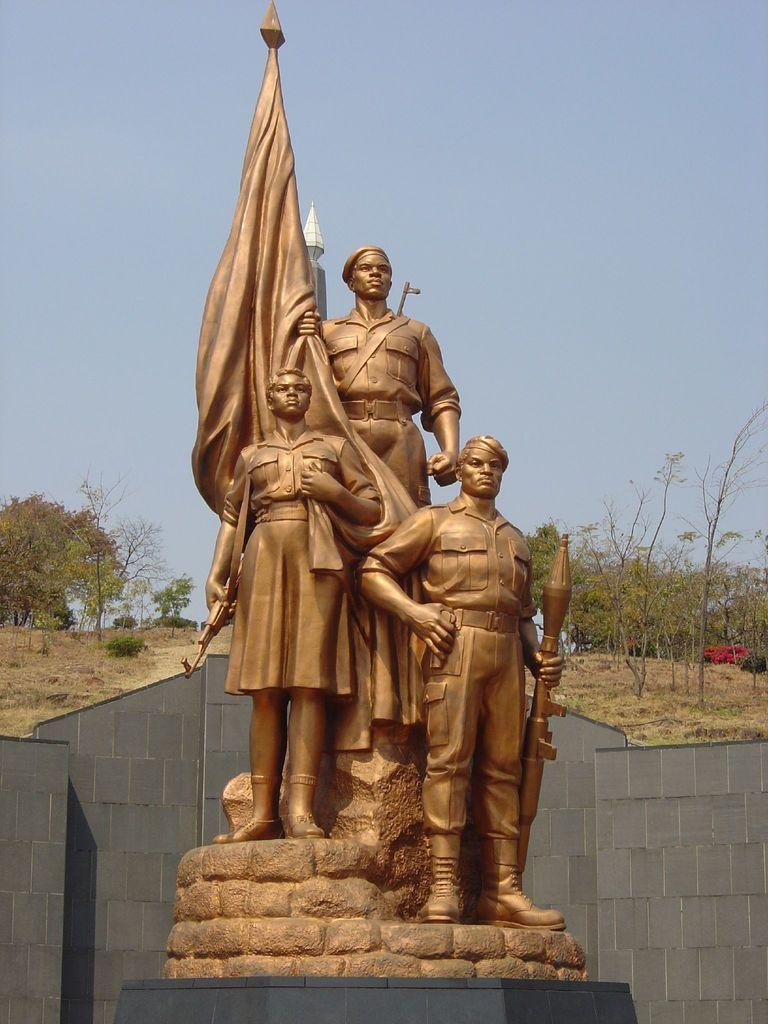What is the main subject in the middle of the image? There are statues in the middle of the image. What is located behind the statues? There is a wall behind the statues. What type of vegetation is visible behind the wall? There are trees behind the wall. What is visible at the top of the image? The sky is visible at the top of the image. What type of bell can be heard ringing in the image? There is no bell present in the image, and therefore no sound can be heard. 